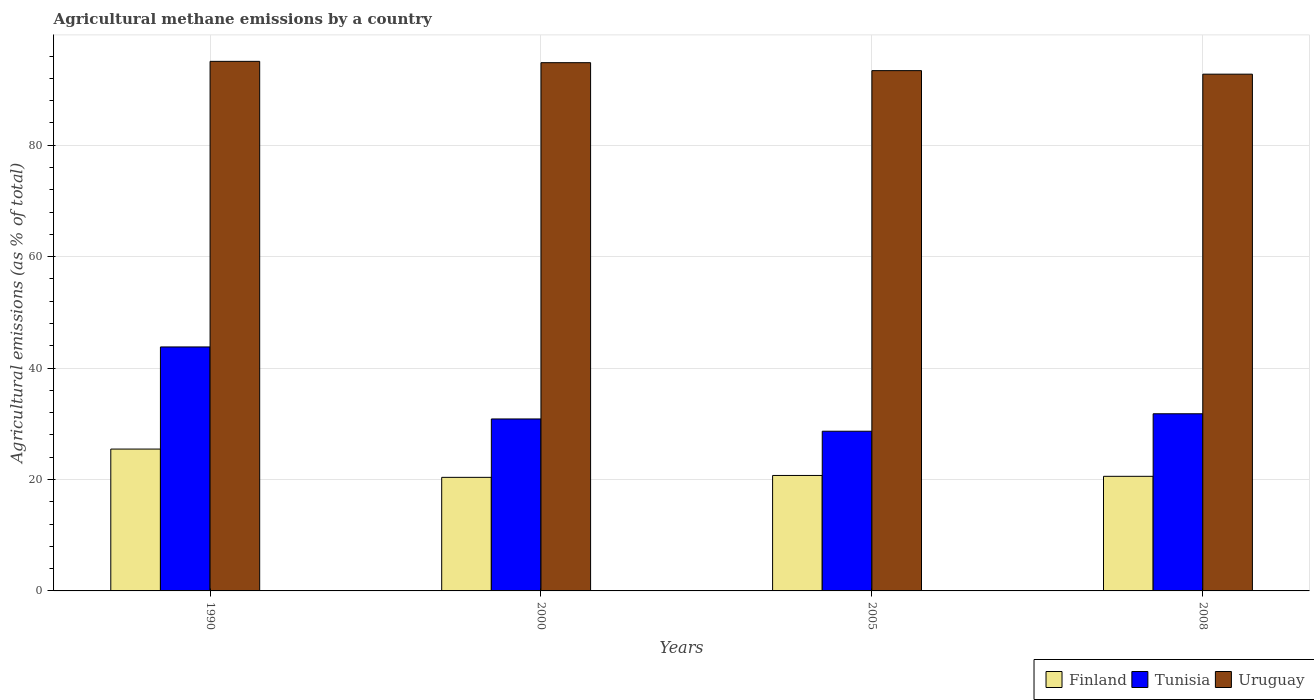How many groups of bars are there?
Keep it short and to the point. 4. Are the number of bars on each tick of the X-axis equal?
Provide a succinct answer. Yes. How many bars are there on the 2nd tick from the left?
Your answer should be very brief. 3. How many bars are there on the 3rd tick from the right?
Your response must be concise. 3. What is the amount of agricultural methane emitted in Uruguay in 1990?
Your answer should be compact. 95.06. Across all years, what is the maximum amount of agricultural methane emitted in Tunisia?
Offer a very short reply. 43.79. Across all years, what is the minimum amount of agricultural methane emitted in Tunisia?
Your response must be concise. 28.66. What is the total amount of agricultural methane emitted in Uruguay in the graph?
Your response must be concise. 376.02. What is the difference between the amount of agricultural methane emitted in Tunisia in 1990 and that in 2000?
Give a very brief answer. 12.93. What is the difference between the amount of agricultural methane emitted in Finland in 2008 and the amount of agricultural methane emitted in Uruguay in 2000?
Give a very brief answer. -74.25. What is the average amount of agricultural methane emitted in Uruguay per year?
Make the answer very short. 94.01. In the year 2000, what is the difference between the amount of agricultural methane emitted in Uruguay and amount of agricultural methane emitted in Finland?
Offer a very short reply. 74.43. What is the ratio of the amount of agricultural methane emitted in Tunisia in 2000 to that in 2008?
Make the answer very short. 0.97. What is the difference between the highest and the second highest amount of agricultural methane emitted in Finland?
Keep it short and to the point. 4.74. What is the difference between the highest and the lowest amount of agricultural methane emitted in Uruguay?
Make the answer very short. 2.3. What does the 3rd bar from the left in 2005 represents?
Provide a short and direct response. Uruguay. What does the 1st bar from the right in 2005 represents?
Your answer should be compact. Uruguay. Is it the case that in every year, the sum of the amount of agricultural methane emitted in Finland and amount of agricultural methane emitted in Tunisia is greater than the amount of agricultural methane emitted in Uruguay?
Provide a short and direct response. No. What is the difference between two consecutive major ticks on the Y-axis?
Make the answer very short. 20. Does the graph contain grids?
Your answer should be compact. Yes. What is the title of the graph?
Your response must be concise. Agricultural methane emissions by a country. Does "Faeroe Islands" appear as one of the legend labels in the graph?
Your answer should be compact. No. What is the label or title of the X-axis?
Your response must be concise. Years. What is the label or title of the Y-axis?
Your answer should be very brief. Agricultural emissions (as % of total). What is the Agricultural emissions (as % of total) of Finland in 1990?
Offer a terse response. 25.46. What is the Agricultural emissions (as % of total) in Tunisia in 1990?
Offer a terse response. 43.79. What is the Agricultural emissions (as % of total) of Uruguay in 1990?
Offer a very short reply. 95.06. What is the Agricultural emissions (as % of total) in Finland in 2000?
Ensure brevity in your answer.  20.38. What is the Agricultural emissions (as % of total) of Tunisia in 2000?
Make the answer very short. 30.87. What is the Agricultural emissions (as % of total) of Uruguay in 2000?
Your answer should be compact. 94.82. What is the Agricultural emissions (as % of total) in Finland in 2005?
Give a very brief answer. 20.73. What is the Agricultural emissions (as % of total) in Tunisia in 2005?
Offer a terse response. 28.66. What is the Agricultural emissions (as % of total) of Uruguay in 2005?
Your answer should be very brief. 93.39. What is the Agricultural emissions (as % of total) of Finland in 2008?
Ensure brevity in your answer.  20.57. What is the Agricultural emissions (as % of total) in Tunisia in 2008?
Give a very brief answer. 31.8. What is the Agricultural emissions (as % of total) of Uruguay in 2008?
Make the answer very short. 92.76. Across all years, what is the maximum Agricultural emissions (as % of total) in Finland?
Keep it short and to the point. 25.46. Across all years, what is the maximum Agricultural emissions (as % of total) of Tunisia?
Make the answer very short. 43.79. Across all years, what is the maximum Agricultural emissions (as % of total) of Uruguay?
Offer a very short reply. 95.06. Across all years, what is the minimum Agricultural emissions (as % of total) in Finland?
Your answer should be compact. 20.38. Across all years, what is the minimum Agricultural emissions (as % of total) of Tunisia?
Your response must be concise. 28.66. Across all years, what is the minimum Agricultural emissions (as % of total) in Uruguay?
Offer a very short reply. 92.76. What is the total Agricultural emissions (as % of total) of Finland in the graph?
Keep it short and to the point. 87.14. What is the total Agricultural emissions (as % of total) in Tunisia in the graph?
Your response must be concise. 135.12. What is the total Agricultural emissions (as % of total) of Uruguay in the graph?
Offer a very short reply. 376.02. What is the difference between the Agricultural emissions (as % of total) in Finland in 1990 and that in 2000?
Your answer should be very brief. 5.08. What is the difference between the Agricultural emissions (as % of total) of Tunisia in 1990 and that in 2000?
Keep it short and to the point. 12.93. What is the difference between the Agricultural emissions (as % of total) in Uruguay in 1990 and that in 2000?
Make the answer very short. 0.24. What is the difference between the Agricultural emissions (as % of total) in Finland in 1990 and that in 2005?
Provide a succinct answer. 4.74. What is the difference between the Agricultural emissions (as % of total) of Tunisia in 1990 and that in 2005?
Offer a very short reply. 15.13. What is the difference between the Agricultural emissions (as % of total) of Uruguay in 1990 and that in 2005?
Your response must be concise. 1.67. What is the difference between the Agricultural emissions (as % of total) in Finland in 1990 and that in 2008?
Make the answer very short. 4.89. What is the difference between the Agricultural emissions (as % of total) of Tunisia in 1990 and that in 2008?
Provide a short and direct response. 11.99. What is the difference between the Agricultural emissions (as % of total) of Uruguay in 1990 and that in 2008?
Offer a very short reply. 2.3. What is the difference between the Agricultural emissions (as % of total) in Finland in 2000 and that in 2005?
Keep it short and to the point. -0.34. What is the difference between the Agricultural emissions (as % of total) of Tunisia in 2000 and that in 2005?
Provide a short and direct response. 2.2. What is the difference between the Agricultural emissions (as % of total) of Uruguay in 2000 and that in 2005?
Your answer should be compact. 1.43. What is the difference between the Agricultural emissions (as % of total) of Finland in 2000 and that in 2008?
Offer a terse response. -0.19. What is the difference between the Agricultural emissions (as % of total) in Tunisia in 2000 and that in 2008?
Ensure brevity in your answer.  -0.93. What is the difference between the Agricultural emissions (as % of total) of Uruguay in 2000 and that in 2008?
Your answer should be very brief. 2.06. What is the difference between the Agricultural emissions (as % of total) of Finland in 2005 and that in 2008?
Your answer should be compact. 0.15. What is the difference between the Agricultural emissions (as % of total) of Tunisia in 2005 and that in 2008?
Your answer should be very brief. -3.14. What is the difference between the Agricultural emissions (as % of total) of Uruguay in 2005 and that in 2008?
Give a very brief answer. 0.63. What is the difference between the Agricultural emissions (as % of total) in Finland in 1990 and the Agricultural emissions (as % of total) in Tunisia in 2000?
Make the answer very short. -5.41. What is the difference between the Agricultural emissions (as % of total) in Finland in 1990 and the Agricultural emissions (as % of total) in Uruguay in 2000?
Your answer should be very brief. -69.36. What is the difference between the Agricultural emissions (as % of total) in Tunisia in 1990 and the Agricultural emissions (as % of total) in Uruguay in 2000?
Offer a very short reply. -51.03. What is the difference between the Agricultural emissions (as % of total) of Finland in 1990 and the Agricultural emissions (as % of total) of Tunisia in 2005?
Make the answer very short. -3.2. What is the difference between the Agricultural emissions (as % of total) in Finland in 1990 and the Agricultural emissions (as % of total) in Uruguay in 2005?
Provide a short and direct response. -67.93. What is the difference between the Agricultural emissions (as % of total) of Tunisia in 1990 and the Agricultural emissions (as % of total) of Uruguay in 2005?
Your answer should be compact. -49.6. What is the difference between the Agricultural emissions (as % of total) of Finland in 1990 and the Agricultural emissions (as % of total) of Tunisia in 2008?
Your answer should be compact. -6.34. What is the difference between the Agricultural emissions (as % of total) in Finland in 1990 and the Agricultural emissions (as % of total) in Uruguay in 2008?
Provide a short and direct response. -67.3. What is the difference between the Agricultural emissions (as % of total) of Tunisia in 1990 and the Agricultural emissions (as % of total) of Uruguay in 2008?
Your answer should be very brief. -48.96. What is the difference between the Agricultural emissions (as % of total) of Finland in 2000 and the Agricultural emissions (as % of total) of Tunisia in 2005?
Your answer should be compact. -8.28. What is the difference between the Agricultural emissions (as % of total) in Finland in 2000 and the Agricultural emissions (as % of total) in Uruguay in 2005?
Keep it short and to the point. -73. What is the difference between the Agricultural emissions (as % of total) in Tunisia in 2000 and the Agricultural emissions (as % of total) in Uruguay in 2005?
Make the answer very short. -62.52. What is the difference between the Agricultural emissions (as % of total) in Finland in 2000 and the Agricultural emissions (as % of total) in Tunisia in 2008?
Offer a very short reply. -11.41. What is the difference between the Agricultural emissions (as % of total) of Finland in 2000 and the Agricultural emissions (as % of total) of Uruguay in 2008?
Make the answer very short. -72.37. What is the difference between the Agricultural emissions (as % of total) of Tunisia in 2000 and the Agricultural emissions (as % of total) of Uruguay in 2008?
Offer a very short reply. -61.89. What is the difference between the Agricultural emissions (as % of total) of Finland in 2005 and the Agricultural emissions (as % of total) of Tunisia in 2008?
Give a very brief answer. -11.07. What is the difference between the Agricultural emissions (as % of total) of Finland in 2005 and the Agricultural emissions (as % of total) of Uruguay in 2008?
Make the answer very short. -72.03. What is the difference between the Agricultural emissions (as % of total) of Tunisia in 2005 and the Agricultural emissions (as % of total) of Uruguay in 2008?
Provide a short and direct response. -64.09. What is the average Agricultural emissions (as % of total) in Finland per year?
Make the answer very short. 21.79. What is the average Agricultural emissions (as % of total) in Tunisia per year?
Give a very brief answer. 33.78. What is the average Agricultural emissions (as % of total) in Uruguay per year?
Your response must be concise. 94.01. In the year 1990, what is the difference between the Agricultural emissions (as % of total) in Finland and Agricultural emissions (as % of total) in Tunisia?
Your answer should be very brief. -18.33. In the year 1990, what is the difference between the Agricultural emissions (as % of total) in Finland and Agricultural emissions (as % of total) in Uruguay?
Provide a succinct answer. -69.59. In the year 1990, what is the difference between the Agricultural emissions (as % of total) of Tunisia and Agricultural emissions (as % of total) of Uruguay?
Make the answer very short. -51.26. In the year 2000, what is the difference between the Agricultural emissions (as % of total) of Finland and Agricultural emissions (as % of total) of Tunisia?
Ensure brevity in your answer.  -10.48. In the year 2000, what is the difference between the Agricultural emissions (as % of total) in Finland and Agricultural emissions (as % of total) in Uruguay?
Offer a terse response. -74.43. In the year 2000, what is the difference between the Agricultural emissions (as % of total) of Tunisia and Agricultural emissions (as % of total) of Uruguay?
Your answer should be very brief. -63.95. In the year 2005, what is the difference between the Agricultural emissions (as % of total) in Finland and Agricultural emissions (as % of total) in Tunisia?
Provide a short and direct response. -7.94. In the year 2005, what is the difference between the Agricultural emissions (as % of total) of Finland and Agricultural emissions (as % of total) of Uruguay?
Offer a terse response. -72.66. In the year 2005, what is the difference between the Agricultural emissions (as % of total) of Tunisia and Agricultural emissions (as % of total) of Uruguay?
Give a very brief answer. -64.73. In the year 2008, what is the difference between the Agricultural emissions (as % of total) of Finland and Agricultural emissions (as % of total) of Tunisia?
Your answer should be compact. -11.23. In the year 2008, what is the difference between the Agricultural emissions (as % of total) of Finland and Agricultural emissions (as % of total) of Uruguay?
Give a very brief answer. -72.19. In the year 2008, what is the difference between the Agricultural emissions (as % of total) in Tunisia and Agricultural emissions (as % of total) in Uruguay?
Provide a short and direct response. -60.96. What is the ratio of the Agricultural emissions (as % of total) of Finland in 1990 to that in 2000?
Your answer should be compact. 1.25. What is the ratio of the Agricultural emissions (as % of total) of Tunisia in 1990 to that in 2000?
Give a very brief answer. 1.42. What is the ratio of the Agricultural emissions (as % of total) in Uruguay in 1990 to that in 2000?
Make the answer very short. 1. What is the ratio of the Agricultural emissions (as % of total) in Finland in 1990 to that in 2005?
Your response must be concise. 1.23. What is the ratio of the Agricultural emissions (as % of total) in Tunisia in 1990 to that in 2005?
Make the answer very short. 1.53. What is the ratio of the Agricultural emissions (as % of total) of Uruguay in 1990 to that in 2005?
Keep it short and to the point. 1.02. What is the ratio of the Agricultural emissions (as % of total) in Finland in 1990 to that in 2008?
Keep it short and to the point. 1.24. What is the ratio of the Agricultural emissions (as % of total) in Tunisia in 1990 to that in 2008?
Ensure brevity in your answer.  1.38. What is the ratio of the Agricultural emissions (as % of total) in Uruguay in 1990 to that in 2008?
Keep it short and to the point. 1.02. What is the ratio of the Agricultural emissions (as % of total) of Finland in 2000 to that in 2005?
Provide a succinct answer. 0.98. What is the ratio of the Agricultural emissions (as % of total) of Tunisia in 2000 to that in 2005?
Make the answer very short. 1.08. What is the ratio of the Agricultural emissions (as % of total) of Uruguay in 2000 to that in 2005?
Provide a short and direct response. 1.02. What is the ratio of the Agricultural emissions (as % of total) in Finland in 2000 to that in 2008?
Your answer should be very brief. 0.99. What is the ratio of the Agricultural emissions (as % of total) of Tunisia in 2000 to that in 2008?
Keep it short and to the point. 0.97. What is the ratio of the Agricultural emissions (as % of total) of Uruguay in 2000 to that in 2008?
Provide a succinct answer. 1.02. What is the ratio of the Agricultural emissions (as % of total) of Finland in 2005 to that in 2008?
Your response must be concise. 1.01. What is the ratio of the Agricultural emissions (as % of total) in Tunisia in 2005 to that in 2008?
Give a very brief answer. 0.9. What is the ratio of the Agricultural emissions (as % of total) in Uruguay in 2005 to that in 2008?
Give a very brief answer. 1.01. What is the difference between the highest and the second highest Agricultural emissions (as % of total) of Finland?
Offer a terse response. 4.74. What is the difference between the highest and the second highest Agricultural emissions (as % of total) of Tunisia?
Your response must be concise. 11.99. What is the difference between the highest and the second highest Agricultural emissions (as % of total) in Uruguay?
Ensure brevity in your answer.  0.24. What is the difference between the highest and the lowest Agricultural emissions (as % of total) of Finland?
Provide a short and direct response. 5.08. What is the difference between the highest and the lowest Agricultural emissions (as % of total) of Tunisia?
Make the answer very short. 15.13. What is the difference between the highest and the lowest Agricultural emissions (as % of total) in Uruguay?
Make the answer very short. 2.3. 